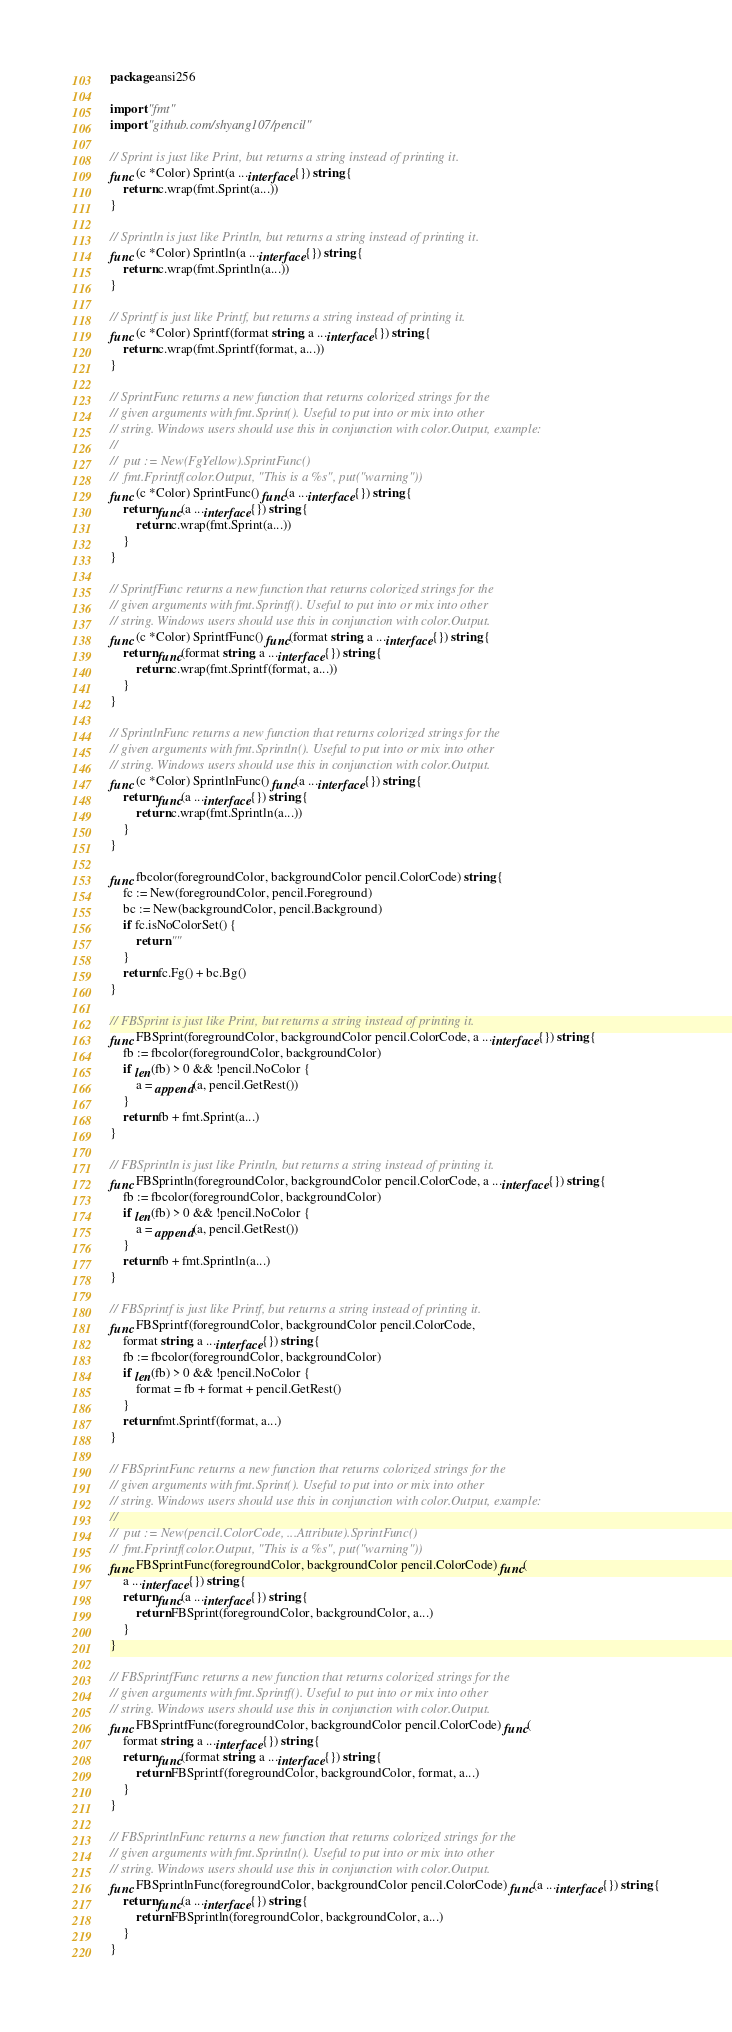Convert code to text. <code><loc_0><loc_0><loc_500><loc_500><_Go_>package ansi256

import "fmt"
import "github.com/shyang107/pencil"

// Sprint is just like Print, but returns a string instead of printing it.
func (c *Color) Sprint(a ...interface{}) string {
	return c.wrap(fmt.Sprint(a...))
}

// Sprintln is just like Println, but returns a string instead of printing it.
func (c *Color) Sprintln(a ...interface{}) string {
	return c.wrap(fmt.Sprintln(a...))
}

// Sprintf is just like Printf, but returns a string instead of printing it.
func (c *Color) Sprintf(format string, a ...interface{}) string {
	return c.wrap(fmt.Sprintf(format, a...))
}

// SprintFunc returns a new function that returns colorized strings for the
// given arguments with fmt.Sprint(). Useful to put into or mix into other
// string. Windows users should use this in conjunction with color.Output, example:
//
//	put := New(FgYellow).SprintFunc()
//	fmt.Fprintf(color.Output, "This is a %s", put("warning"))
func (c *Color) SprintFunc() func(a ...interface{}) string {
	return func(a ...interface{}) string {
		return c.wrap(fmt.Sprint(a...))
	}
}

// SprintfFunc returns a new function that returns colorized strings for the
// given arguments with fmt.Sprintf(). Useful to put into or mix into other
// string. Windows users should use this in conjunction with color.Output.
func (c *Color) SprintfFunc() func(format string, a ...interface{}) string {
	return func(format string, a ...interface{}) string {
		return c.wrap(fmt.Sprintf(format, a...))
	}
}

// SprintlnFunc returns a new function that returns colorized strings for the
// given arguments with fmt.Sprintln(). Useful to put into or mix into other
// string. Windows users should use this in conjunction with color.Output.
func (c *Color) SprintlnFunc() func(a ...interface{}) string {
	return func(a ...interface{}) string {
		return c.wrap(fmt.Sprintln(a...))
	}
}

func fbcolor(foregroundColor, backgroundColor pencil.ColorCode) string {
	fc := New(foregroundColor, pencil.Foreground)
	bc := New(backgroundColor, pencil.Background)
	if fc.isNoColorSet() {
		return ""
	}
	return fc.Fg() + bc.Bg()
}

// FBSprint is just like Print, but returns a string instead of printing it.
func FBSprint(foregroundColor, backgroundColor pencil.ColorCode, a ...interface{}) string {
	fb := fbcolor(foregroundColor, backgroundColor)
	if len(fb) > 0 && !pencil.NoColor {
		a = append(a, pencil.GetRest())
	}
	return fb + fmt.Sprint(a...)
}

// FBSprintln is just like Println, but returns a string instead of printing it.
func FBSprintln(foregroundColor, backgroundColor pencil.ColorCode, a ...interface{}) string {
	fb := fbcolor(foregroundColor, backgroundColor)
	if len(fb) > 0 && !pencil.NoColor {
		a = append(a, pencil.GetRest())
	}
	return fb + fmt.Sprintln(a...)
}

// FBSprintf is just like Printf, but returns a string instead of printing it.
func FBSprintf(foregroundColor, backgroundColor pencil.ColorCode,
	format string, a ...interface{}) string {
	fb := fbcolor(foregroundColor, backgroundColor)
	if len(fb) > 0 && !pencil.NoColor {
		format = fb + format + pencil.GetRest()
	}
	return fmt.Sprintf(format, a...)
}

// FBSprintFunc returns a new function that returns colorized strings for the
// given arguments with fmt.Sprint(). Useful to put into or mix into other
// string. Windows users should use this in conjunction with color.Output, example:
//
//	put := New(pencil.ColorCode, ...Attribute).SprintFunc()
//	fmt.Fprintf(color.Output, "This is a %s", put("warning"))
func FBSprintFunc(foregroundColor, backgroundColor pencil.ColorCode) func(
	a ...interface{}) string {
	return func(a ...interface{}) string {
		return FBSprint(foregroundColor, backgroundColor, a...)
	}
}

// FBSprintfFunc returns a new function that returns colorized strings for the
// given arguments with fmt.Sprintf(). Useful to put into or mix into other
// string. Windows users should use this in conjunction with color.Output.
func FBSprintfFunc(foregroundColor, backgroundColor pencil.ColorCode) func(
	format string, a ...interface{}) string {
	return func(format string, a ...interface{}) string {
		return FBSprintf(foregroundColor, backgroundColor, format, a...)
	}
}

// FBSprintlnFunc returns a new function that returns colorized strings for the
// given arguments with fmt.Sprintln(). Useful to put into or mix into other
// string. Windows users should use this in conjunction with color.Output.
func FBSprintlnFunc(foregroundColor, backgroundColor pencil.ColorCode) func(a ...interface{}) string {
	return func(a ...interface{}) string {
		return FBSprintln(foregroundColor, backgroundColor, a...)
	}
}
</code> 